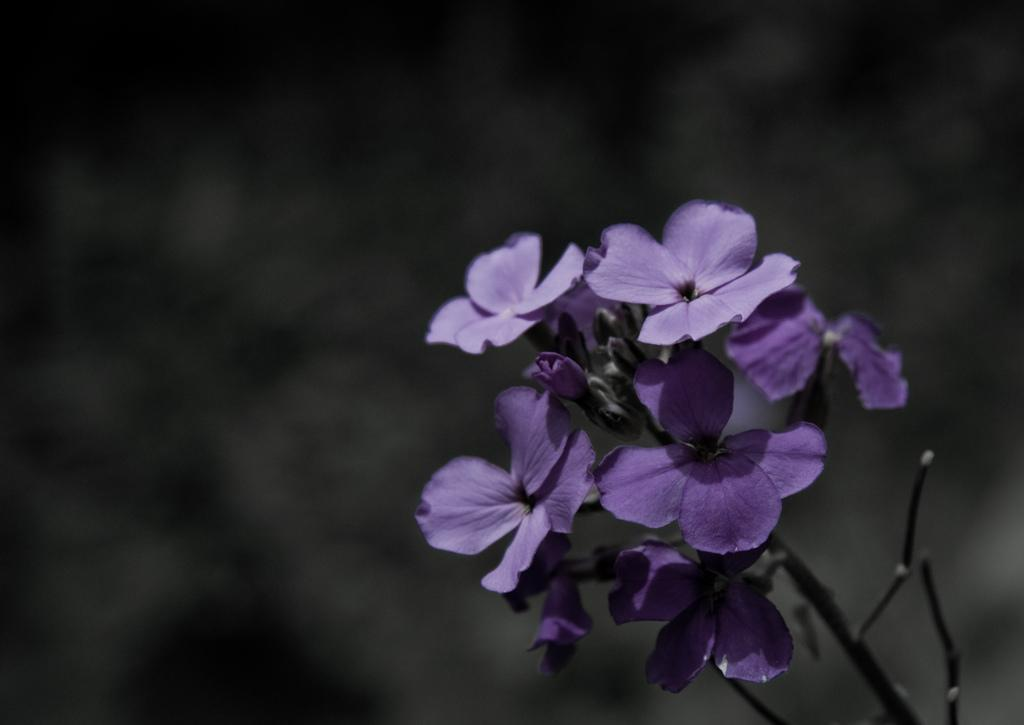What is present in the image? There is a plant in the image. What can be observed about the plant? The plant has flowers. What is the color of the flowers? The flowers are in violet color. How would you describe the background of the image? The background of the image is blurry. How many crows are sitting on the violet flowers in the image? There are no crows present in the image; it features a plant with violet flowers. What type of bit is used to water the plant in the image? There is no bit visible in the image, and the plant does not appear to be receiving water. 